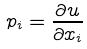Convert formula to latex. <formula><loc_0><loc_0><loc_500><loc_500>p _ { i } = \frac { \partial u } { \partial x _ { i } }</formula> 